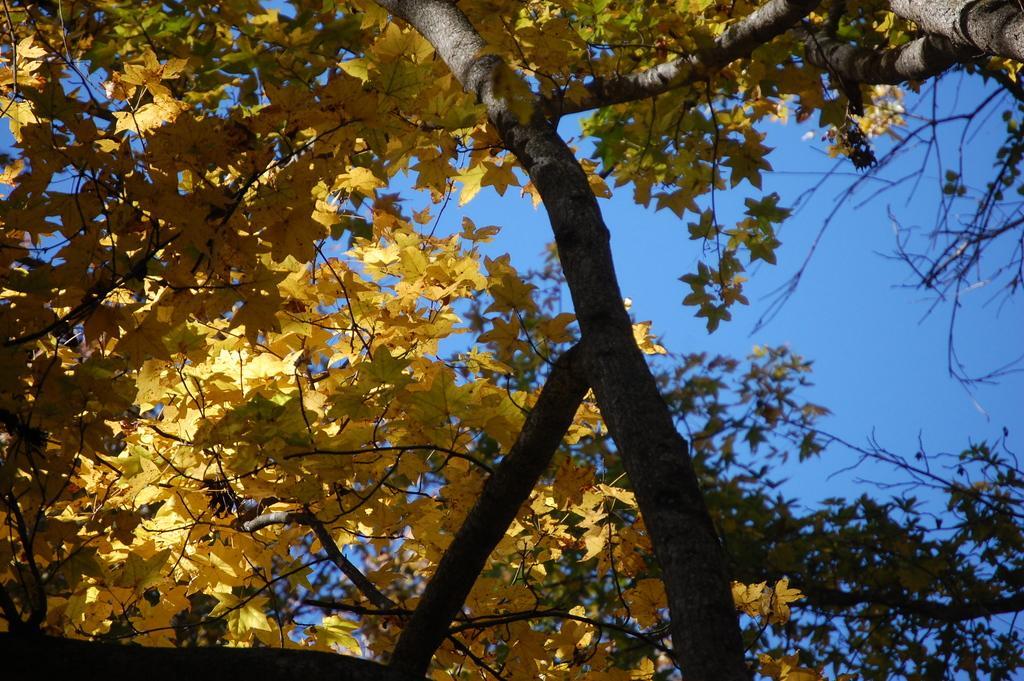Could you give a brief overview of what you see in this image? In this image we can see tree and sky. 